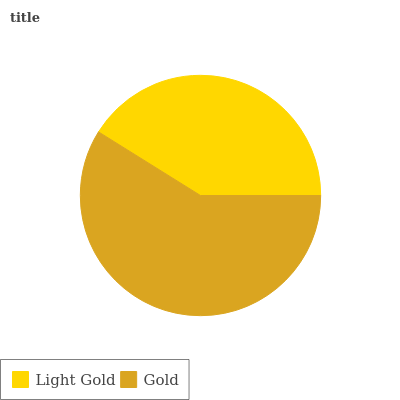Is Light Gold the minimum?
Answer yes or no. Yes. Is Gold the maximum?
Answer yes or no. Yes. Is Gold the minimum?
Answer yes or no. No. Is Gold greater than Light Gold?
Answer yes or no. Yes. Is Light Gold less than Gold?
Answer yes or no. Yes. Is Light Gold greater than Gold?
Answer yes or no. No. Is Gold less than Light Gold?
Answer yes or no. No. Is Gold the high median?
Answer yes or no. Yes. Is Light Gold the low median?
Answer yes or no. Yes. Is Light Gold the high median?
Answer yes or no. No. Is Gold the low median?
Answer yes or no. No. 